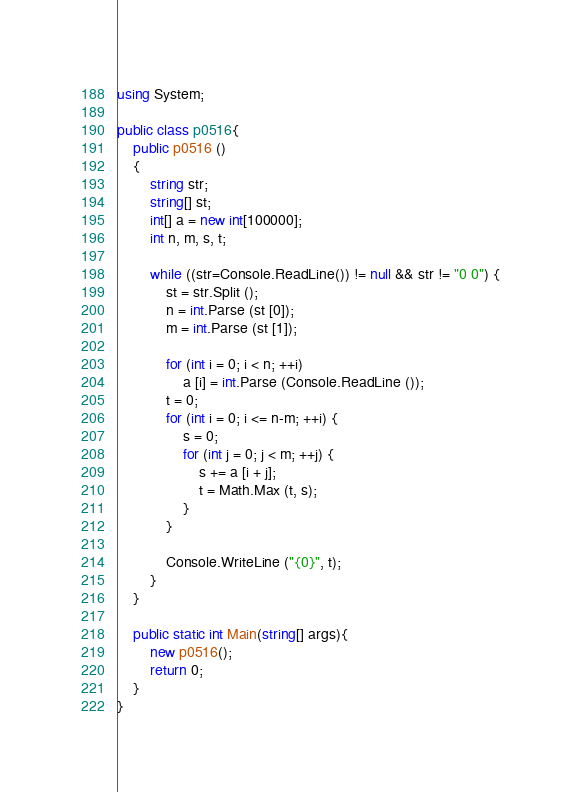<code> <loc_0><loc_0><loc_500><loc_500><_C#_>using System;

public class p0516{
	public p0516 ()
	{
		string str;
		string[] st;
		int[] a = new int[100000];
		int n, m, s, t;
		
		while ((str=Console.ReadLine()) != null && str != "0 0") {
			st = str.Split ();
			n = int.Parse (st [0]);
			m = int.Parse (st [1]);
			
			for (int i = 0; i < n; ++i)
				a [i] = int.Parse (Console.ReadLine ());
			t = 0;
			for (int i = 0; i <= n-m; ++i) {
				s = 0;
				for (int j = 0; j < m; ++j) {
					s += a [i + j];
					t = Math.Max (t, s);
				}
			}
			
			Console.WriteLine ("{0}", t);
		}
	}
	
	public static int Main(string[] args){
		new p0516();
		return 0;
	}
}</code> 